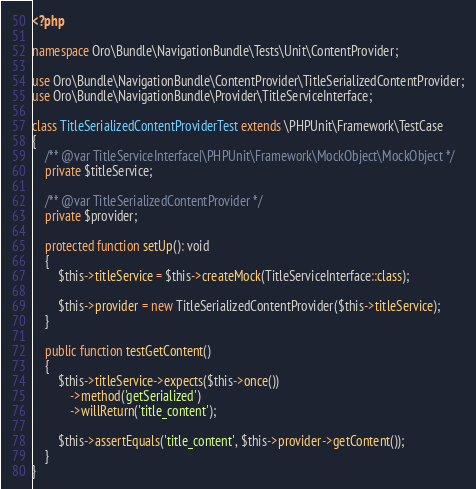Convert code to text. <code><loc_0><loc_0><loc_500><loc_500><_PHP_><?php

namespace Oro\Bundle\NavigationBundle\Tests\Unit\ContentProvider;

use Oro\Bundle\NavigationBundle\ContentProvider\TitleSerializedContentProvider;
use Oro\Bundle\NavigationBundle\Provider\TitleServiceInterface;

class TitleSerializedContentProviderTest extends \PHPUnit\Framework\TestCase
{
    /** @var TitleServiceInterface|\PHPUnit\Framework\MockObject\MockObject */
    private $titleService;

    /** @var TitleSerializedContentProvider */
    private $provider;

    protected function setUp(): void
    {
        $this->titleService = $this->createMock(TitleServiceInterface::class);

        $this->provider = new TitleSerializedContentProvider($this->titleService);
    }

    public function testGetContent()
    {
        $this->titleService->expects($this->once())
            ->method('getSerialized')
            ->willReturn('title_content');

        $this->assertEquals('title_content', $this->provider->getContent());
    }
}
</code> 